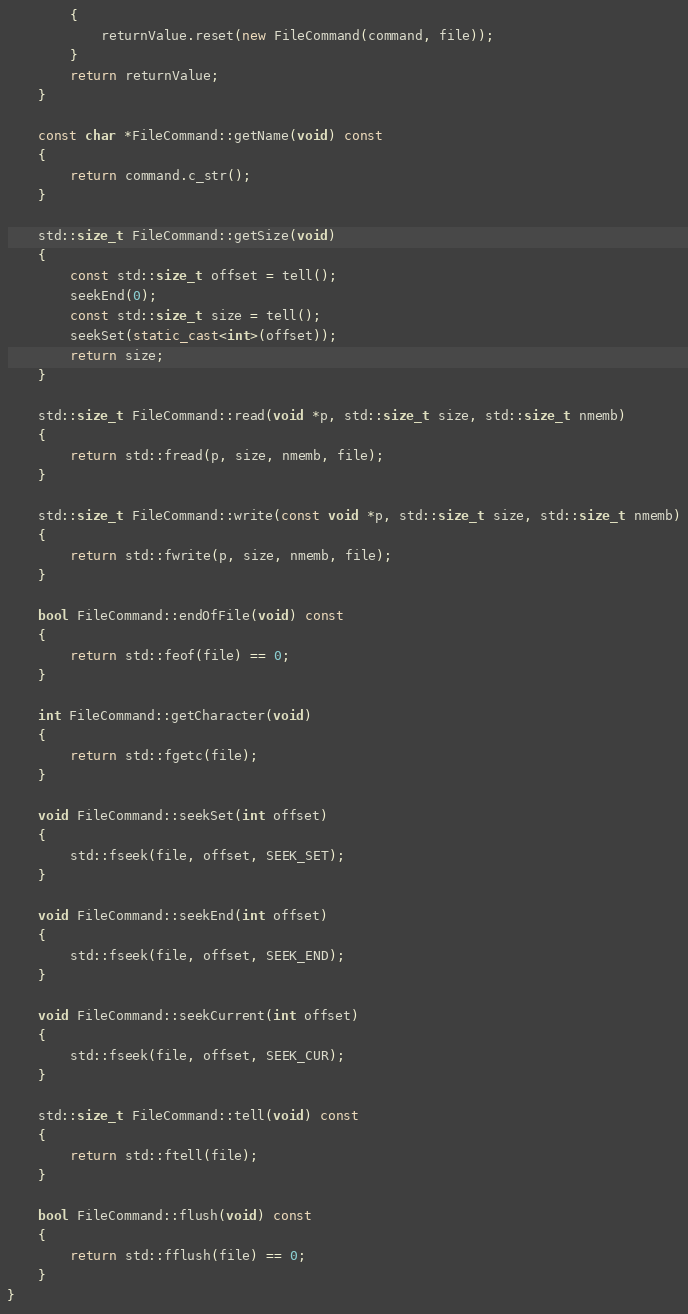Convert code to text. <code><loc_0><loc_0><loc_500><loc_500><_C++_>		{
			returnValue.reset(new FileCommand(command, file));
		}
		return returnValue;
	}

	const char *FileCommand::getName(void) const
	{
		return command.c_str();
	}

	std::size_t FileCommand::getSize(void)
	{
		const std::size_t offset = tell();
		seekEnd(0);
		const std::size_t size = tell();
		seekSet(static_cast<int>(offset));
		return size;
	}

	std::size_t FileCommand::read(void *p, std::size_t size, std::size_t nmemb)
	{
		return std::fread(p, size, nmemb, file);
	}

	std::size_t FileCommand::write(const void *p, std::size_t size, std::size_t nmemb)
	{
		return std::fwrite(p, size, nmemb, file);
	}

	bool FileCommand::endOfFile(void) const
	{
		return std::feof(file) == 0;
	}

	int FileCommand::getCharacter(void)
	{
		return std::fgetc(file);
	}

	void FileCommand::seekSet(int offset)
	{
		std::fseek(file, offset, SEEK_SET);
	}

	void FileCommand::seekEnd(int offset)
	{
		std::fseek(file, offset, SEEK_END);
	}

	void FileCommand::seekCurrent(int offset)
	{
		std::fseek(file, offset, SEEK_CUR);
	}

	std::size_t FileCommand::tell(void) const
	{
		return std::ftell(file);
	}

	bool FileCommand::flush(void) const
	{
		return std::fflush(file) == 0;
	}
}</code> 